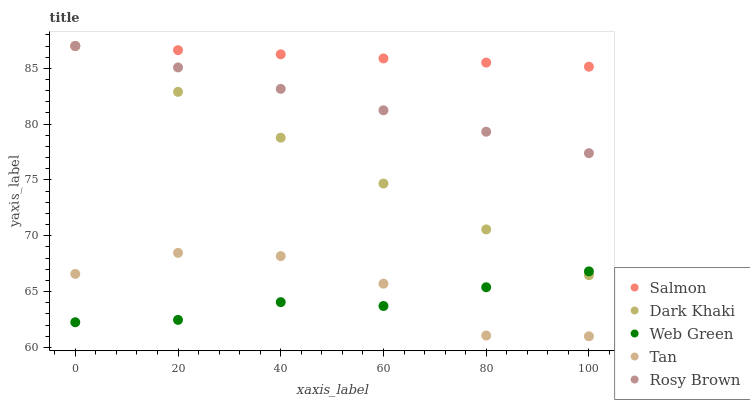Does Web Green have the minimum area under the curve?
Answer yes or no. Yes. Does Salmon have the maximum area under the curve?
Answer yes or no. Yes. Does Tan have the minimum area under the curve?
Answer yes or no. No. Does Tan have the maximum area under the curve?
Answer yes or no. No. Is Dark Khaki the smoothest?
Answer yes or no. Yes. Is Tan the roughest?
Answer yes or no. Yes. Is Rosy Brown the smoothest?
Answer yes or no. No. Is Rosy Brown the roughest?
Answer yes or no. No. Does Tan have the lowest value?
Answer yes or no. Yes. Does Rosy Brown have the lowest value?
Answer yes or no. No. Does Salmon have the highest value?
Answer yes or no. Yes. Does Tan have the highest value?
Answer yes or no. No. Is Tan less than Salmon?
Answer yes or no. Yes. Is Rosy Brown greater than Web Green?
Answer yes or no. Yes. Does Dark Khaki intersect Web Green?
Answer yes or no. Yes. Is Dark Khaki less than Web Green?
Answer yes or no. No. Is Dark Khaki greater than Web Green?
Answer yes or no. No. Does Tan intersect Salmon?
Answer yes or no. No. 